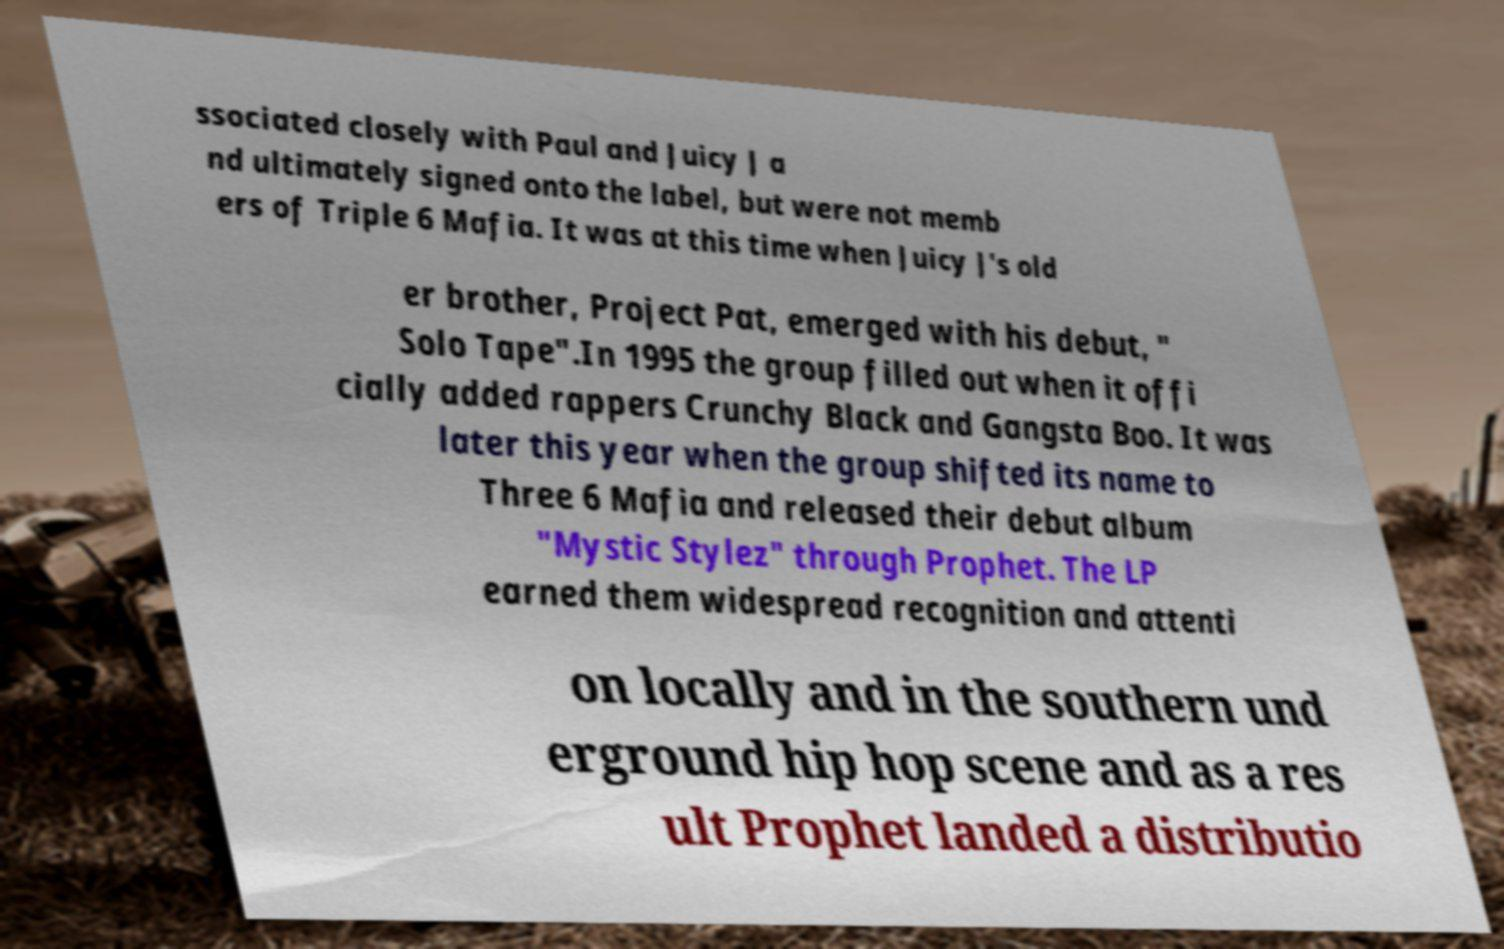Could you assist in decoding the text presented in this image and type it out clearly? ssociated closely with Paul and Juicy J a nd ultimately signed onto the label, but were not memb ers of Triple 6 Mafia. It was at this time when Juicy J's old er brother, Project Pat, emerged with his debut, " Solo Tape".In 1995 the group filled out when it offi cially added rappers Crunchy Black and Gangsta Boo. It was later this year when the group shifted its name to Three 6 Mafia and released their debut album "Mystic Stylez" through Prophet. The LP earned them widespread recognition and attenti on locally and in the southern und erground hip hop scene and as a res ult Prophet landed a distributio 